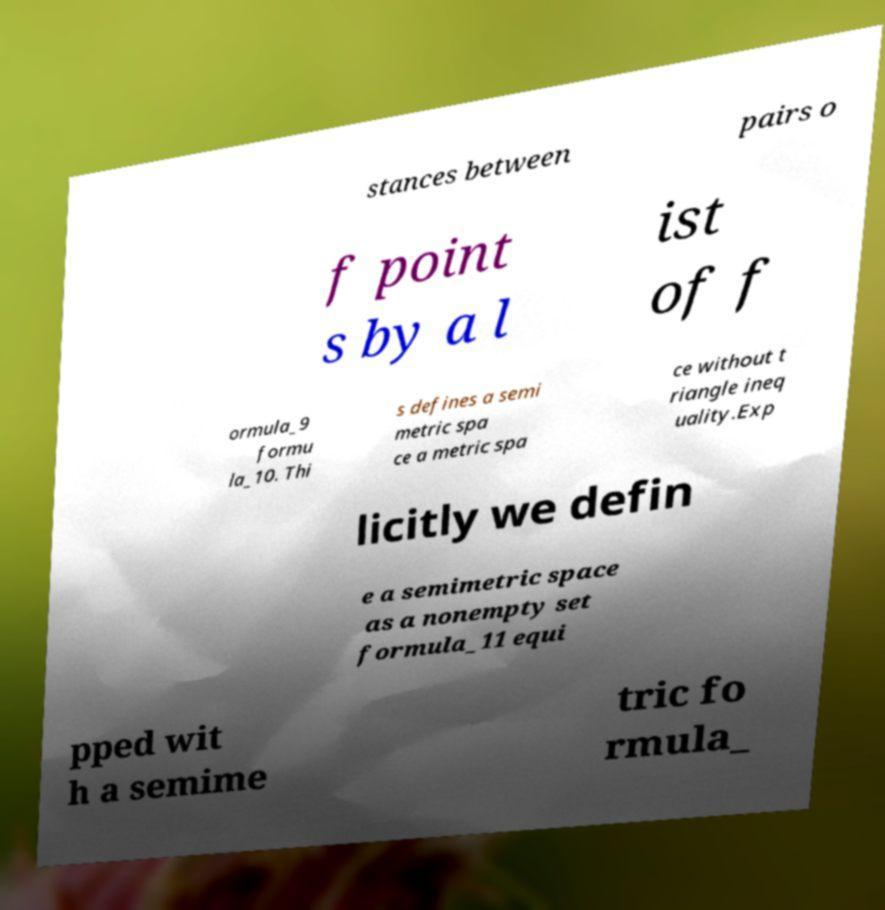For documentation purposes, I need the text within this image transcribed. Could you provide that? stances between pairs o f point s by a l ist of f ormula_9 formu la_10. Thi s defines a semi metric spa ce a metric spa ce without t riangle ineq uality.Exp licitly we defin e a semimetric space as a nonempty set formula_11 equi pped wit h a semime tric fo rmula_ 